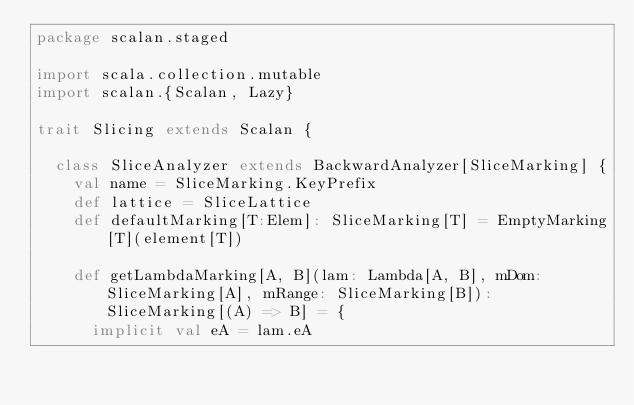Convert code to text. <code><loc_0><loc_0><loc_500><loc_500><_Scala_>package scalan.staged

import scala.collection.mutable
import scalan.{Scalan, Lazy}

trait Slicing extends Scalan {

  class SliceAnalyzer extends BackwardAnalyzer[SliceMarking] {
    val name = SliceMarking.KeyPrefix
    def lattice = SliceLattice
    def defaultMarking[T:Elem]: SliceMarking[T] = EmptyMarking[T](element[T])

    def getLambdaMarking[A, B](lam: Lambda[A, B], mDom: SliceMarking[A], mRange: SliceMarking[B]): SliceMarking[(A) => B] = {
      implicit val eA = lam.eA</code> 